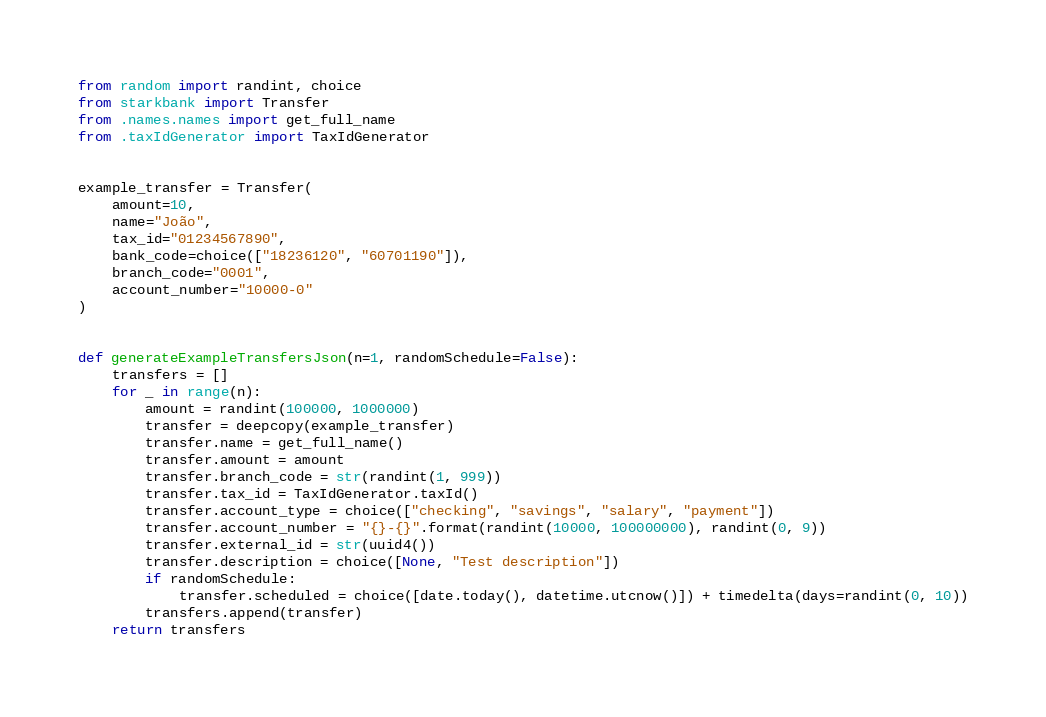Convert code to text. <code><loc_0><loc_0><loc_500><loc_500><_Python_>from random import randint, choice
from starkbank import Transfer
from .names.names import get_full_name
from .taxIdGenerator import TaxIdGenerator


example_transfer = Transfer(
    amount=10,
    name="João",
    tax_id="01234567890",
    bank_code=choice(["18236120", "60701190"]),
    branch_code="0001",
    account_number="10000-0"
)


def generateExampleTransfersJson(n=1, randomSchedule=False):
    transfers = []
    for _ in range(n):
        amount = randint(100000, 1000000)
        transfer = deepcopy(example_transfer)
        transfer.name = get_full_name()
        transfer.amount = amount
        transfer.branch_code = str(randint(1, 999))
        transfer.tax_id = TaxIdGenerator.taxId()
        transfer.account_type = choice(["checking", "savings", "salary", "payment"])
        transfer.account_number = "{}-{}".format(randint(10000, 100000000), randint(0, 9))
        transfer.external_id = str(uuid4())
        transfer.description = choice([None, "Test description"])
        if randomSchedule:
            transfer.scheduled = choice([date.today(), datetime.utcnow()]) + timedelta(days=randint(0, 10))
        transfers.append(transfer)
    return transfers
</code> 